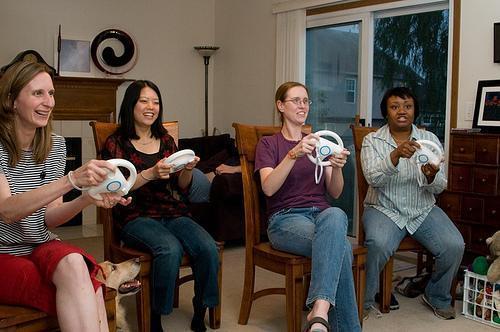What activity is the video game system simulating?
Select the accurate answer and provide explanation: 'Answer: answer
Rationale: rationale.'
Options: Baseball, driving, basketball, karate. Answer: driving.
Rationale: The people are pretending they're using steering wheels. 